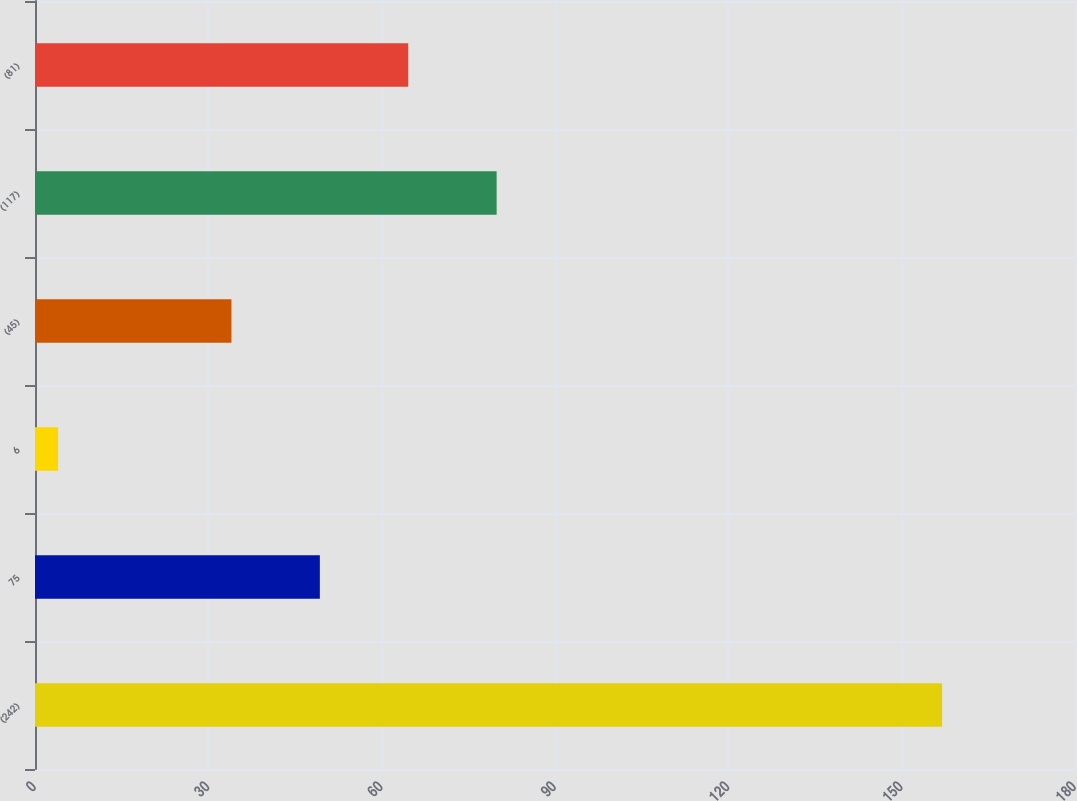Convert chart to OTSL. <chart><loc_0><loc_0><loc_500><loc_500><bar_chart><fcel>(242)<fcel>75<fcel>6<fcel>(45)<fcel>(117)<fcel>(81)<nl><fcel>157<fcel>49.3<fcel>4<fcel>34<fcel>79.9<fcel>64.6<nl></chart> 